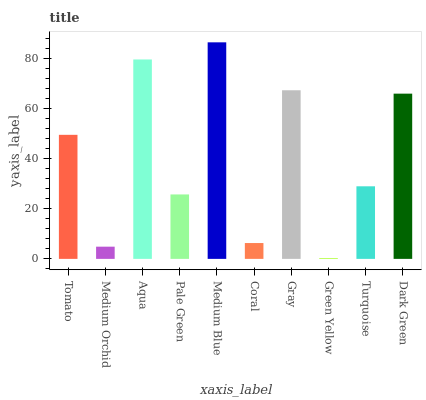Is Green Yellow the minimum?
Answer yes or no. Yes. Is Medium Blue the maximum?
Answer yes or no. Yes. Is Medium Orchid the minimum?
Answer yes or no. No. Is Medium Orchid the maximum?
Answer yes or no. No. Is Tomato greater than Medium Orchid?
Answer yes or no. Yes. Is Medium Orchid less than Tomato?
Answer yes or no. Yes. Is Medium Orchid greater than Tomato?
Answer yes or no. No. Is Tomato less than Medium Orchid?
Answer yes or no. No. Is Tomato the high median?
Answer yes or no. Yes. Is Turquoise the low median?
Answer yes or no. Yes. Is Medium Orchid the high median?
Answer yes or no. No. Is Tomato the low median?
Answer yes or no. No. 